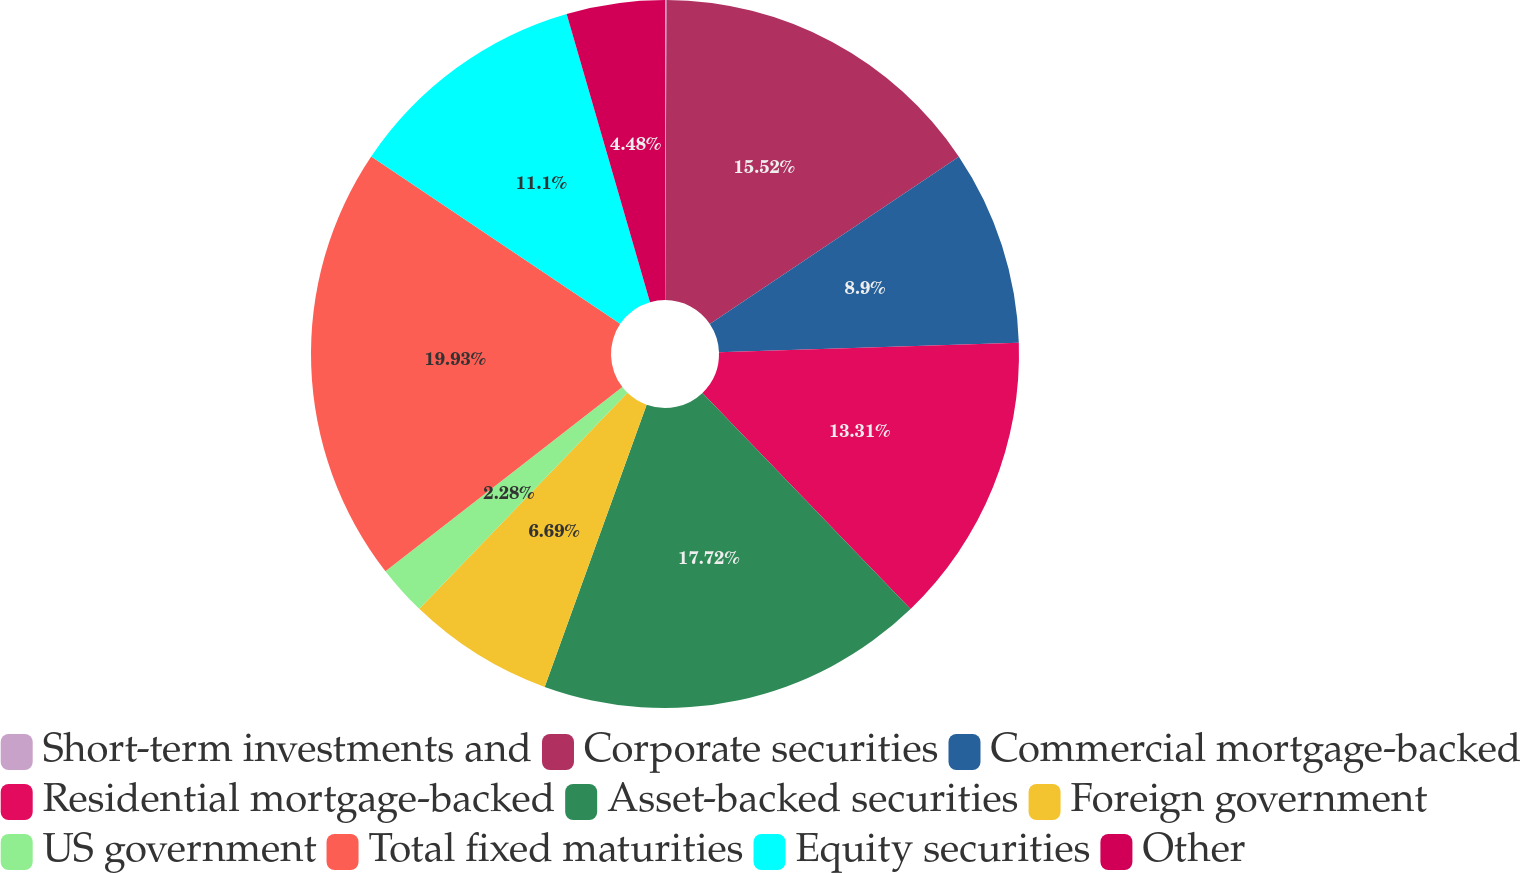Convert chart. <chart><loc_0><loc_0><loc_500><loc_500><pie_chart><fcel>Short-term investments and<fcel>Corporate securities<fcel>Commercial mortgage-backed<fcel>Residential mortgage-backed<fcel>Asset-backed securities<fcel>Foreign government<fcel>US government<fcel>Total fixed maturities<fcel>Equity securities<fcel>Other<nl><fcel>0.07%<fcel>15.52%<fcel>8.9%<fcel>13.31%<fcel>17.72%<fcel>6.69%<fcel>2.28%<fcel>19.93%<fcel>11.1%<fcel>4.48%<nl></chart> 